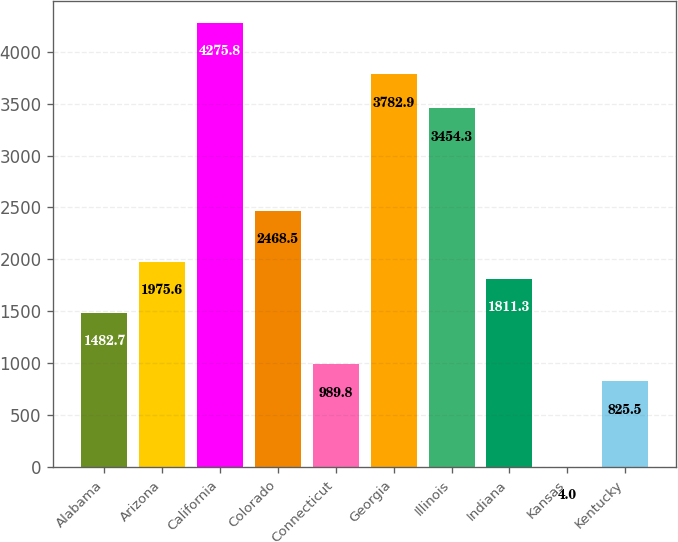<chart> <loc_0><loc_0><loc_500><loc_500><bar_chart><fcel>Alabama<fcel>Arizona<fcel>California<fcel>Colorado<fcel>Connecticut<fcel>Georgia<fcel>Illinois<fcel>Indiana<fcel>Kansas<fcel>Kentucky<nl><fcel>1482.7<fcel>1975.6<fcel>4275.8<fcel>2468.5<fcel>989.8<fcel>3782.9<fcel>3454.3<fcel>1811.3<fcel>4<fcel>825.5<nl></chart> 